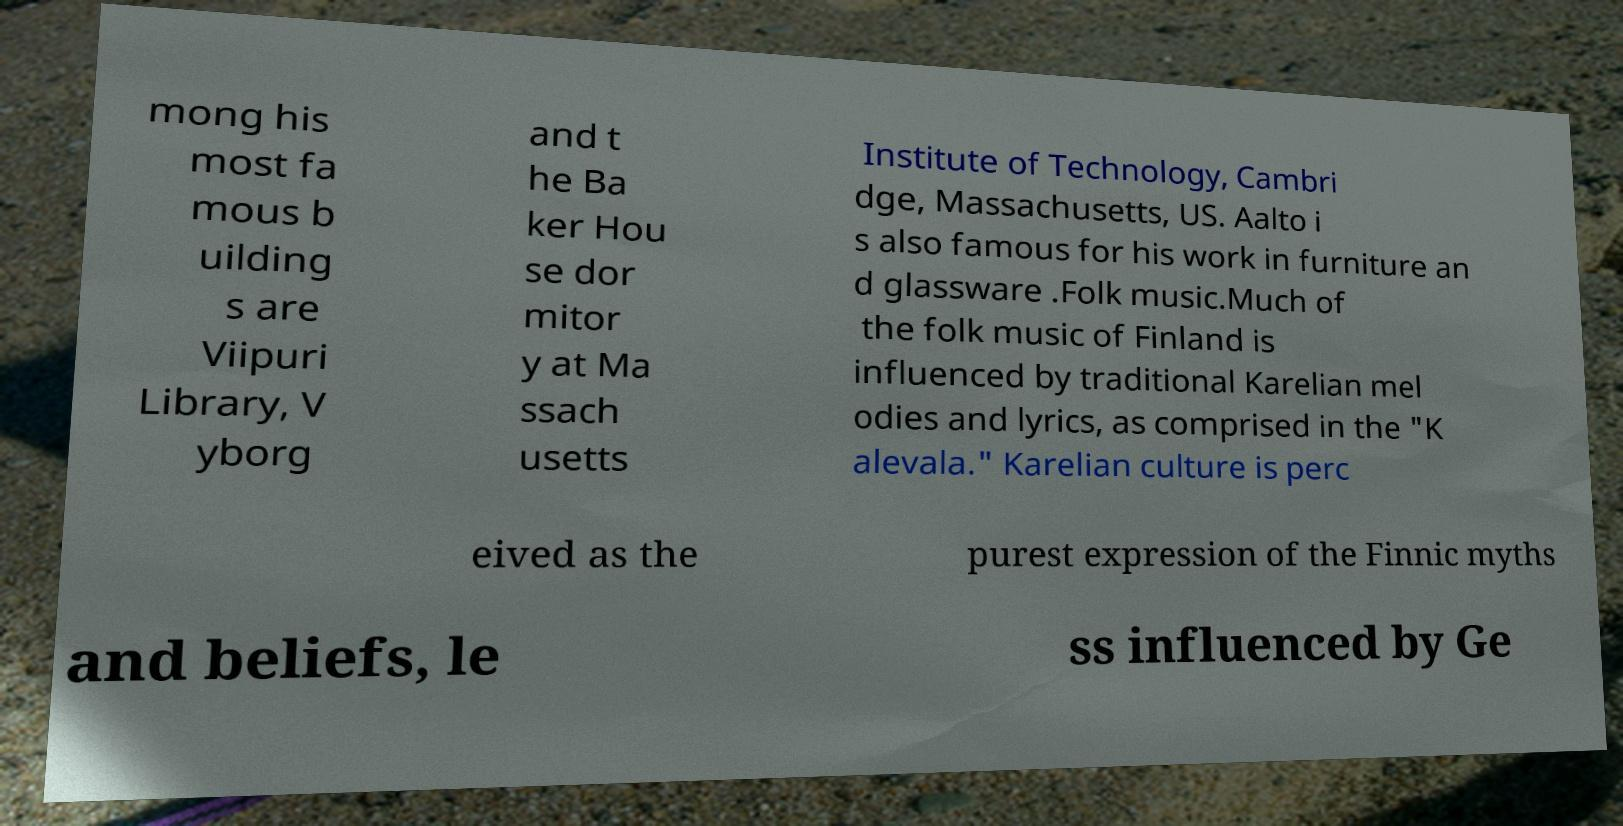What messages or text are displayed in this image? I need them in a readable, typed format. mong his most fa mous b uilding s are Viipuri Library, V yborg and t he Ba ker Hou se dor mitor y at Ma ssach usetts Institute of Technology, Cambri dge, Massachusetts, US. Aalto i s also famous for his work in furniture an d glassware .Folk music.Much of the folk music of Finland is influenced by traditional Karelian mel odies and lyrics, as comprised in the "K alevala." Karelian culture is perc eived as the purest expression of the Finnic myths and beliefs, le ss influenced by Ge 